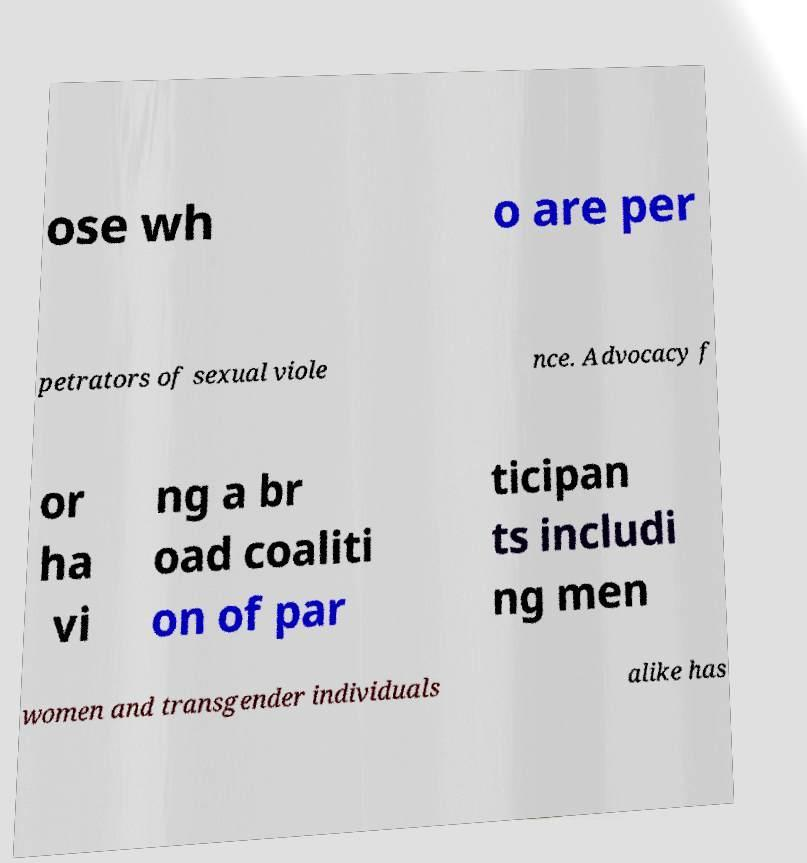Please read and relay the text visible in this image. What does it say? ose wh o are per petrators of sexual viole nce. Advocacy f or ha vi ng a br oad coaliti on of par ticipan ts includi ng men women and transgender individuals alike has 